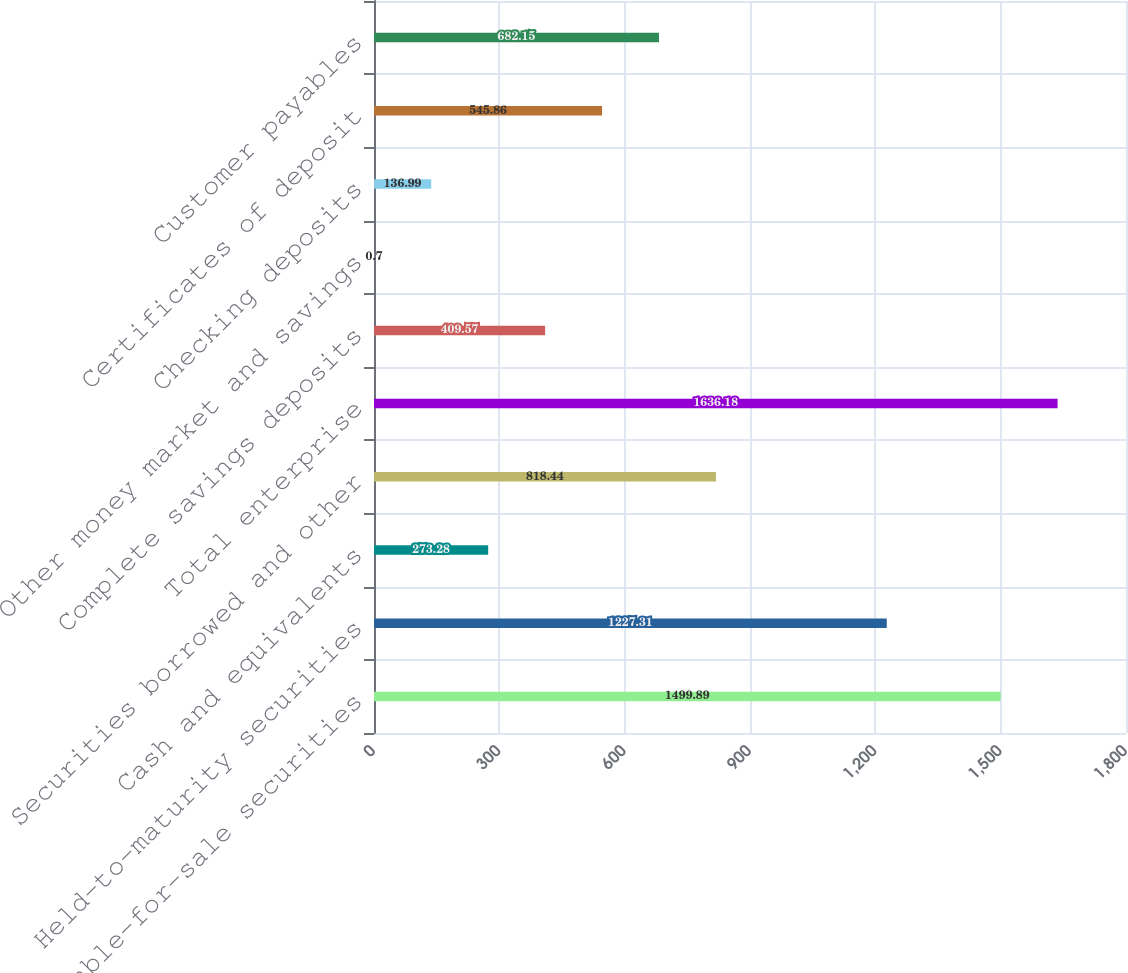<chart> <loc_0><loc_0><loc_500><loc_500><bar_chart><fcel>Available-for-sale securities<fcel>Held-to-maturity securities<fcel>Cash and equivalents<fcel>Securities borrowed and other<fcel>Total enterprise<fcel>Complete savings deposits<fcel>Other money market and savings<fcel>Checking deposits<fcel>Certificates of deposit<fcel>Customer payables<nl><fcel>1499.89<fcel>1227.31<fcel>273.28<fcel>818.44<fcel>1636.18<fcel>409.57<fcel>0.7<fcel>136.99<fcel>545.86<fcel>682.15<nl></chart> 